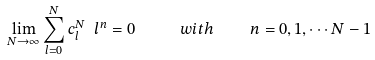<formula> <loc_0><loc_0><loc_500><loc_500>\lim _ { N \rightarrow \infty } \sum _ { l = 0 } ^ { N } c _ { l } ^ { N } \ l ^ { n } = 0 \ \quad w i t h \quad n = 0 , 1 , \cdots N - 1 \,</formula> 